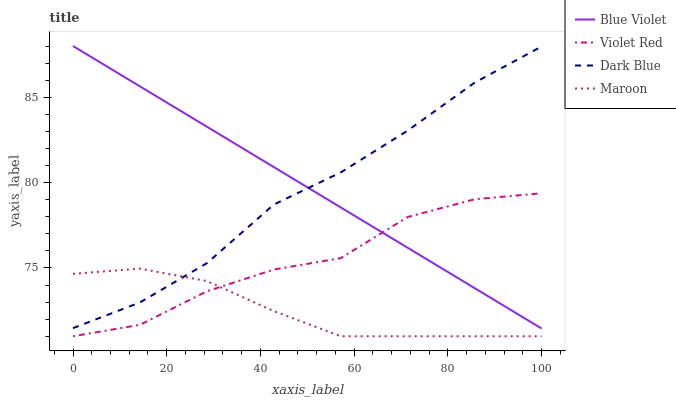Does Maroon have the minimum area under the curve?
Answer yes or no. Yes. Does Blue Violet have the maximum area under the curve?
Answer yes or no. Yes. Does Violet Red have the minimum area under the curve?
Answer yes or no. No. Does Violet Red have the maximum area under the curve?
Answer yes or no. No. Is Blue Violet the smoothest?
Answer yes or no. Yes. Is Violet Red the roughest?
Answer yes or no. Yes. Is Maroon the smoothest?
Answer yes or no. No. Is Maroon the roughest?
Answer yes or no. No. Does Violet Red have the lowest value?
Answer yes or no. Yes. Does Blue Violet have the lowest value?
Answer yes or no. No. Does Blue Violet have the highest value?
Answer yes or no. Yes. Does Violet Red have the highest value?
Answer yes or no. No. Is Maroon less than Blue Violet?
Answer yes or no. Yes. Is Blue Violet greater than Maroon?
Answer yes or no. Yes. Does Violet Red intersect Blue Violet?
Answer yes or no. Yes. Is Violet Red less than Blue Violet?
Answer yes or no. No. Is Violet Red greater than Blue Violet?
Answer yes or no. No. Does Maroon intersect Blue Violet?
Answer yes or no. No. 